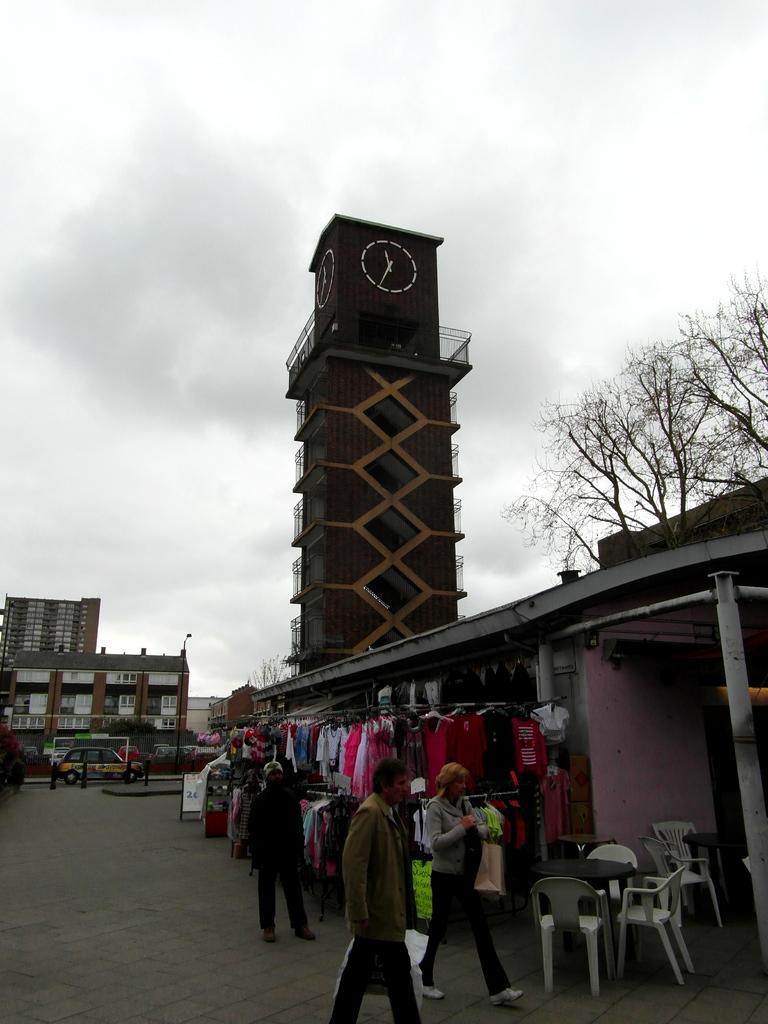How would you summarize this image in a sentence or two? The image is outside of the city. In the image there are three people standing and walking, on right side we can see few dresses and a house,clock tower,trees. In background there is a building and sky is cloudy. 